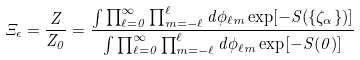Convert formula to latex. <formula><loc_0><loc_0><loc_500><loc_500>\Xi _ { \epsilon } = \frac { Z } { Z _ { 0 } } = \frac { \int \prod _ { \ell = 0 } ^ { \infty } \prod _ { m = - \ell } ^ { \ell } d \phi _ { \ell m } \exp [ - S ( \{ \zeta _ { \alpha } \} ) ] } { \int \prod _ { \ell = 0 } ^ { \infty } \prod _ { m = - \ell } ^ { \ell } d \phi _ { \ell m } \exp [ - S ( 0 ) ] }</formula> 